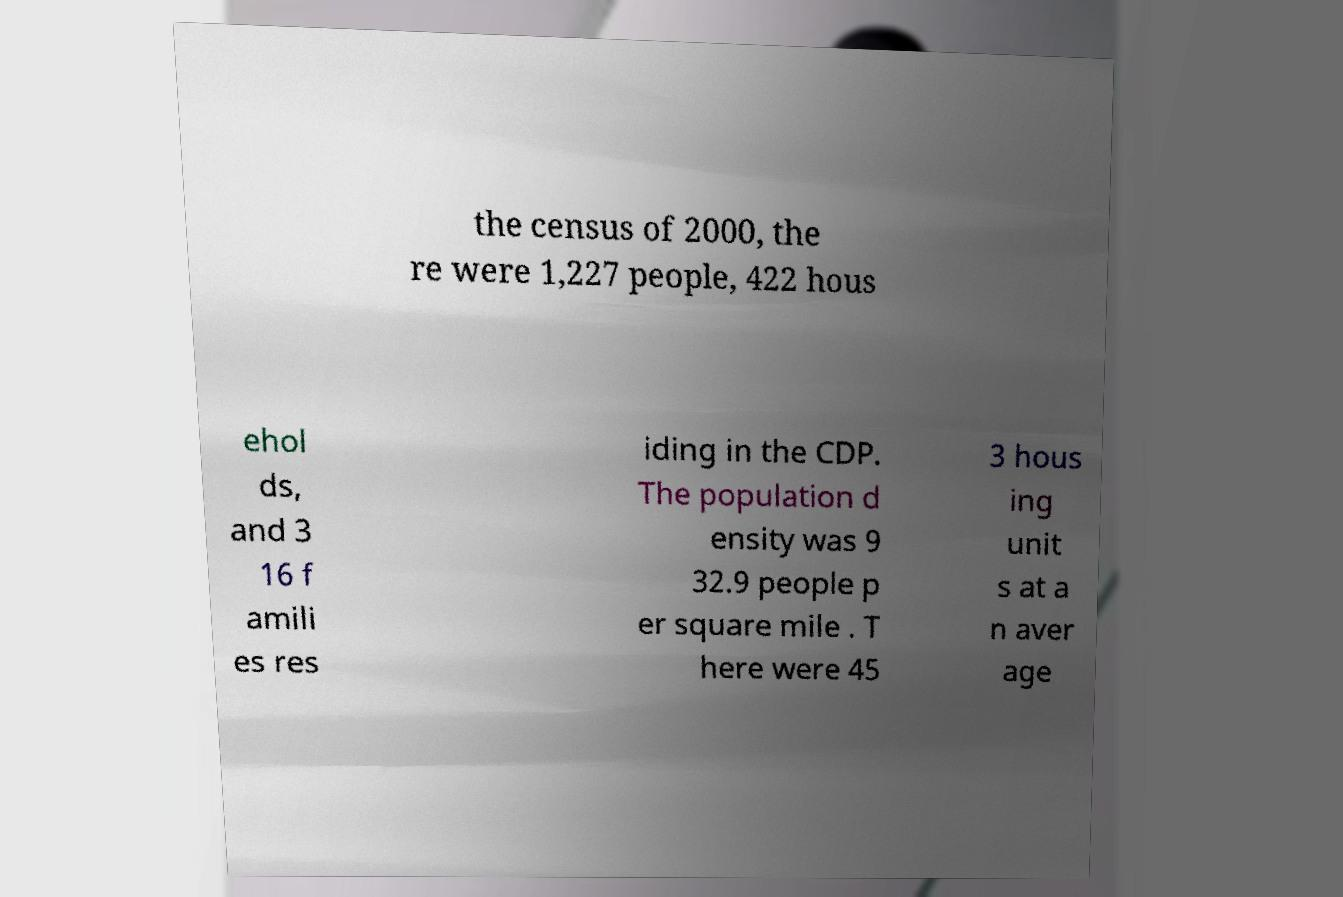Can you accurately transcribe the text from the provided image for me? the census of 2000, the re were 1,227 people, 422 hous ehol ds, and 3 16 f amili es res iding in the CDP. The population d ensity was 9 32.9 people p er square mile . T here were 45 3 hous ing unit s at a n aver age 